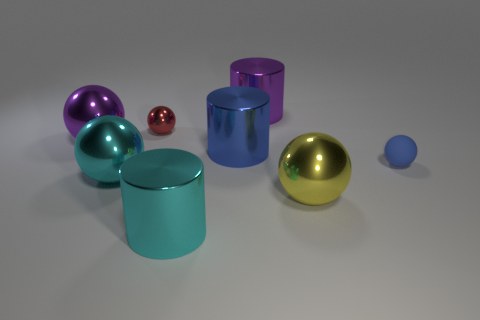Subtract all red balls. How many balls are left? 4 Subtract all purple balls. How many balls are left? 4 Subtract all brown spheres. Subtract all green cubes. How many spheres are left? 5 Add 1 blue spheres. How many objects exist? 9 Subtract all cylinders. How many objects are left? 5 Subtract 0 green cubes. How many objects are left? 8 Subtract all red blocks. Subtract all tiny rubber things. How many objects are left? 7 Add 6 big yellow metal balls. How many big yellow metal balls are left? 7 Add 1 big yellow metallic blocks. How many big yellow metallic blocks exist? 1 